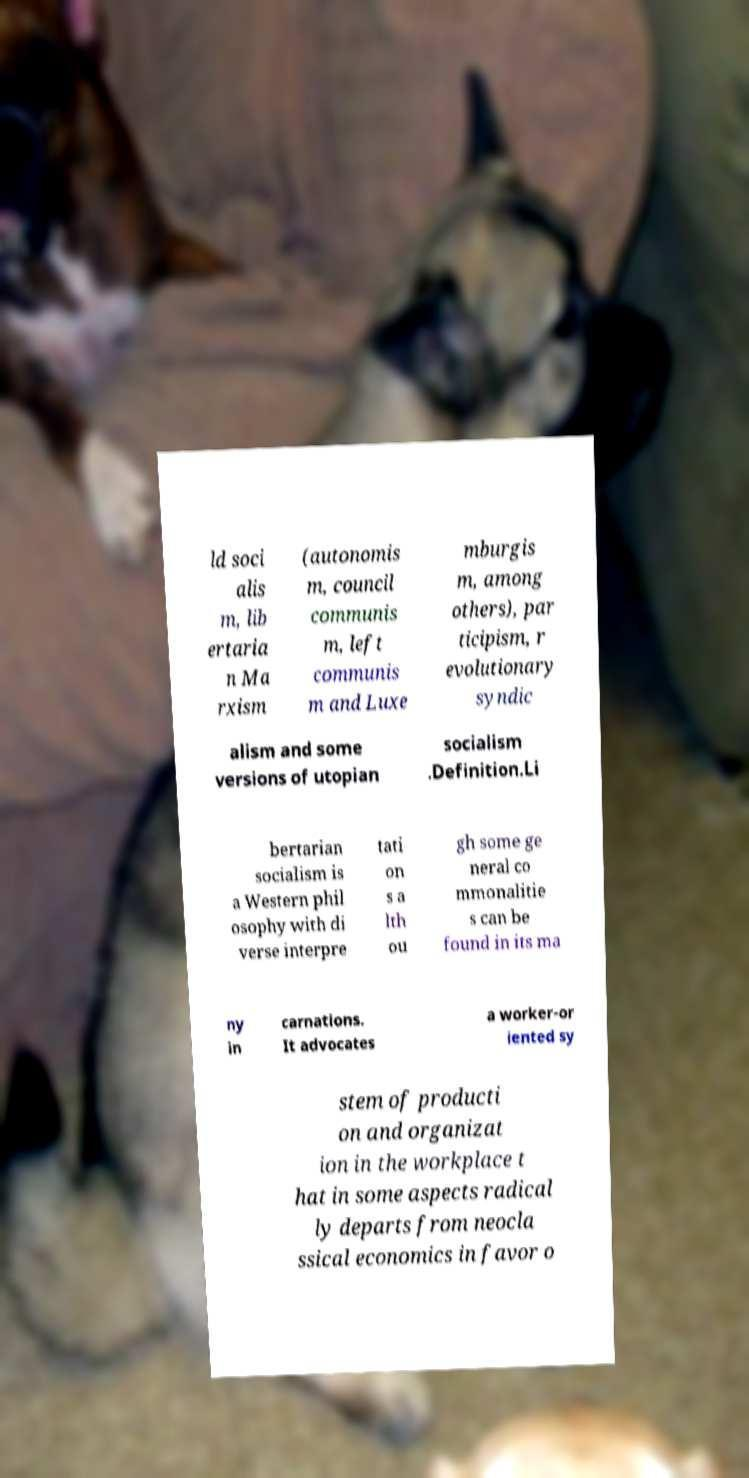Can you accurately transcribe the text from the provided image for me? ld soci alis m, lib ertaria n Ma rxism (autonomis m, council communis m, left communis m and Luxe mburgis m, among others), par ticipism, r evolutionary syndic alism and some versions of utopian socialism .Definition.Li bertarian socialism is a Western phil osophy with di verse interpre tati on s a lth ou gh some ge neral co mmonalitie s can be found in its ma ny in carnations. It advocates a worker-or iented sy stem of producti on and organizat ion in the workplace t hat in some aspects radical ly departs from neocla ssical economics in favor o 